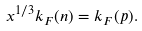<formula> <loc_0><loc_0><loc_500><loc_500>x ^ { 1 / 3 } k _ { F } ( n ) = k _ { F } ( p ) .</formula> 